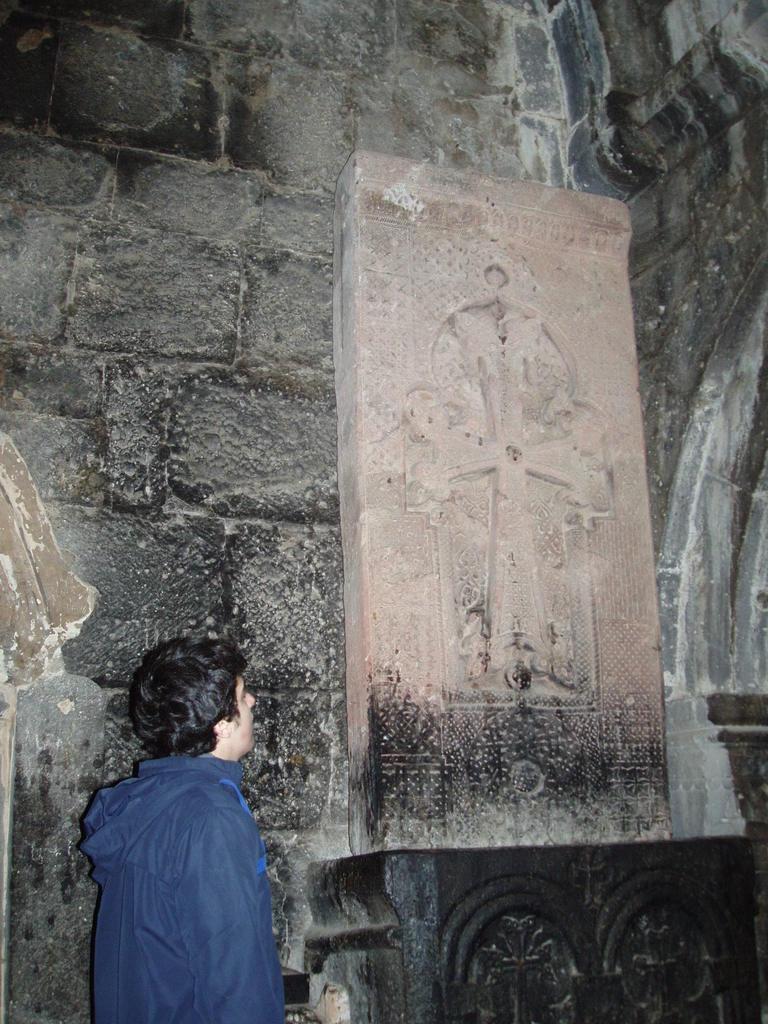How would you summarize this image in a sentence or two? In this picture there is a man and we can see cemetery on the platform. In the background of the image we can see wall. 